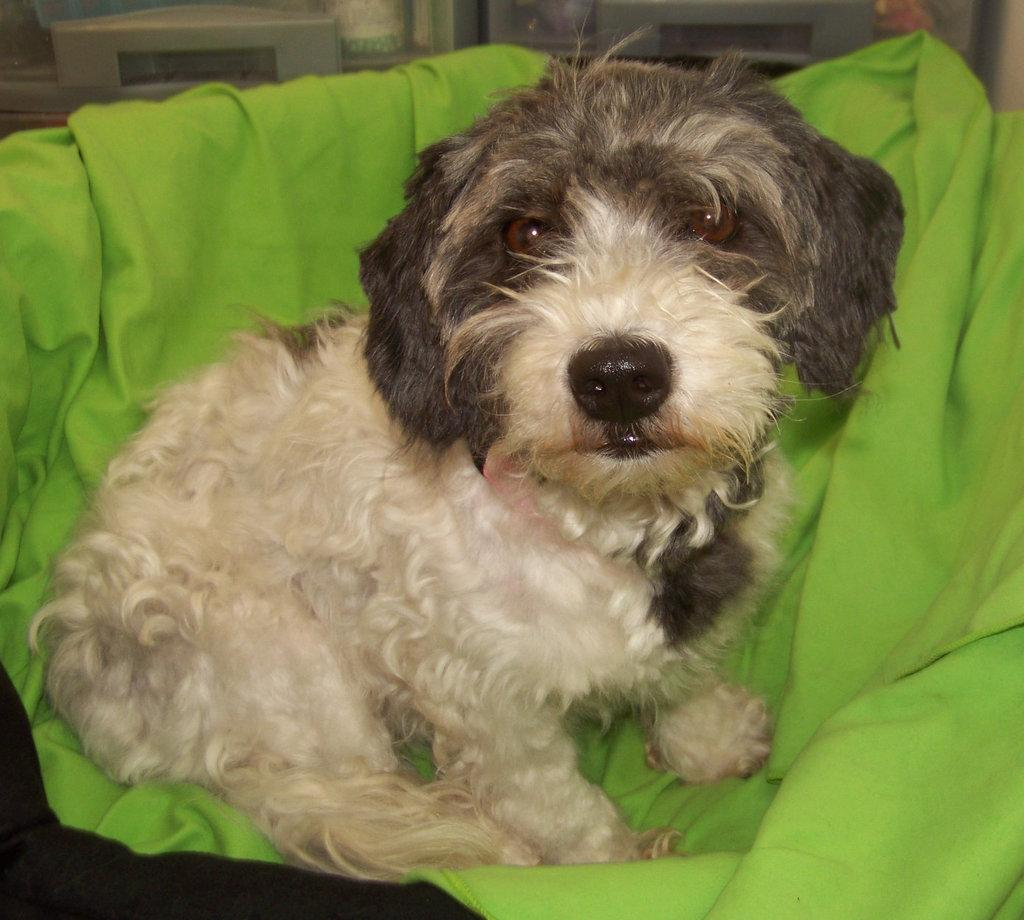What is the main subject in the center of the image? There is a dog in the center of the image. What is located at the bottom of the image? There is a cloth at the bottom of the image. What type of music is the dog playing in the image? There is no music or instrument present in the image, so it cannot be determined what type of music the dog might be playing. 